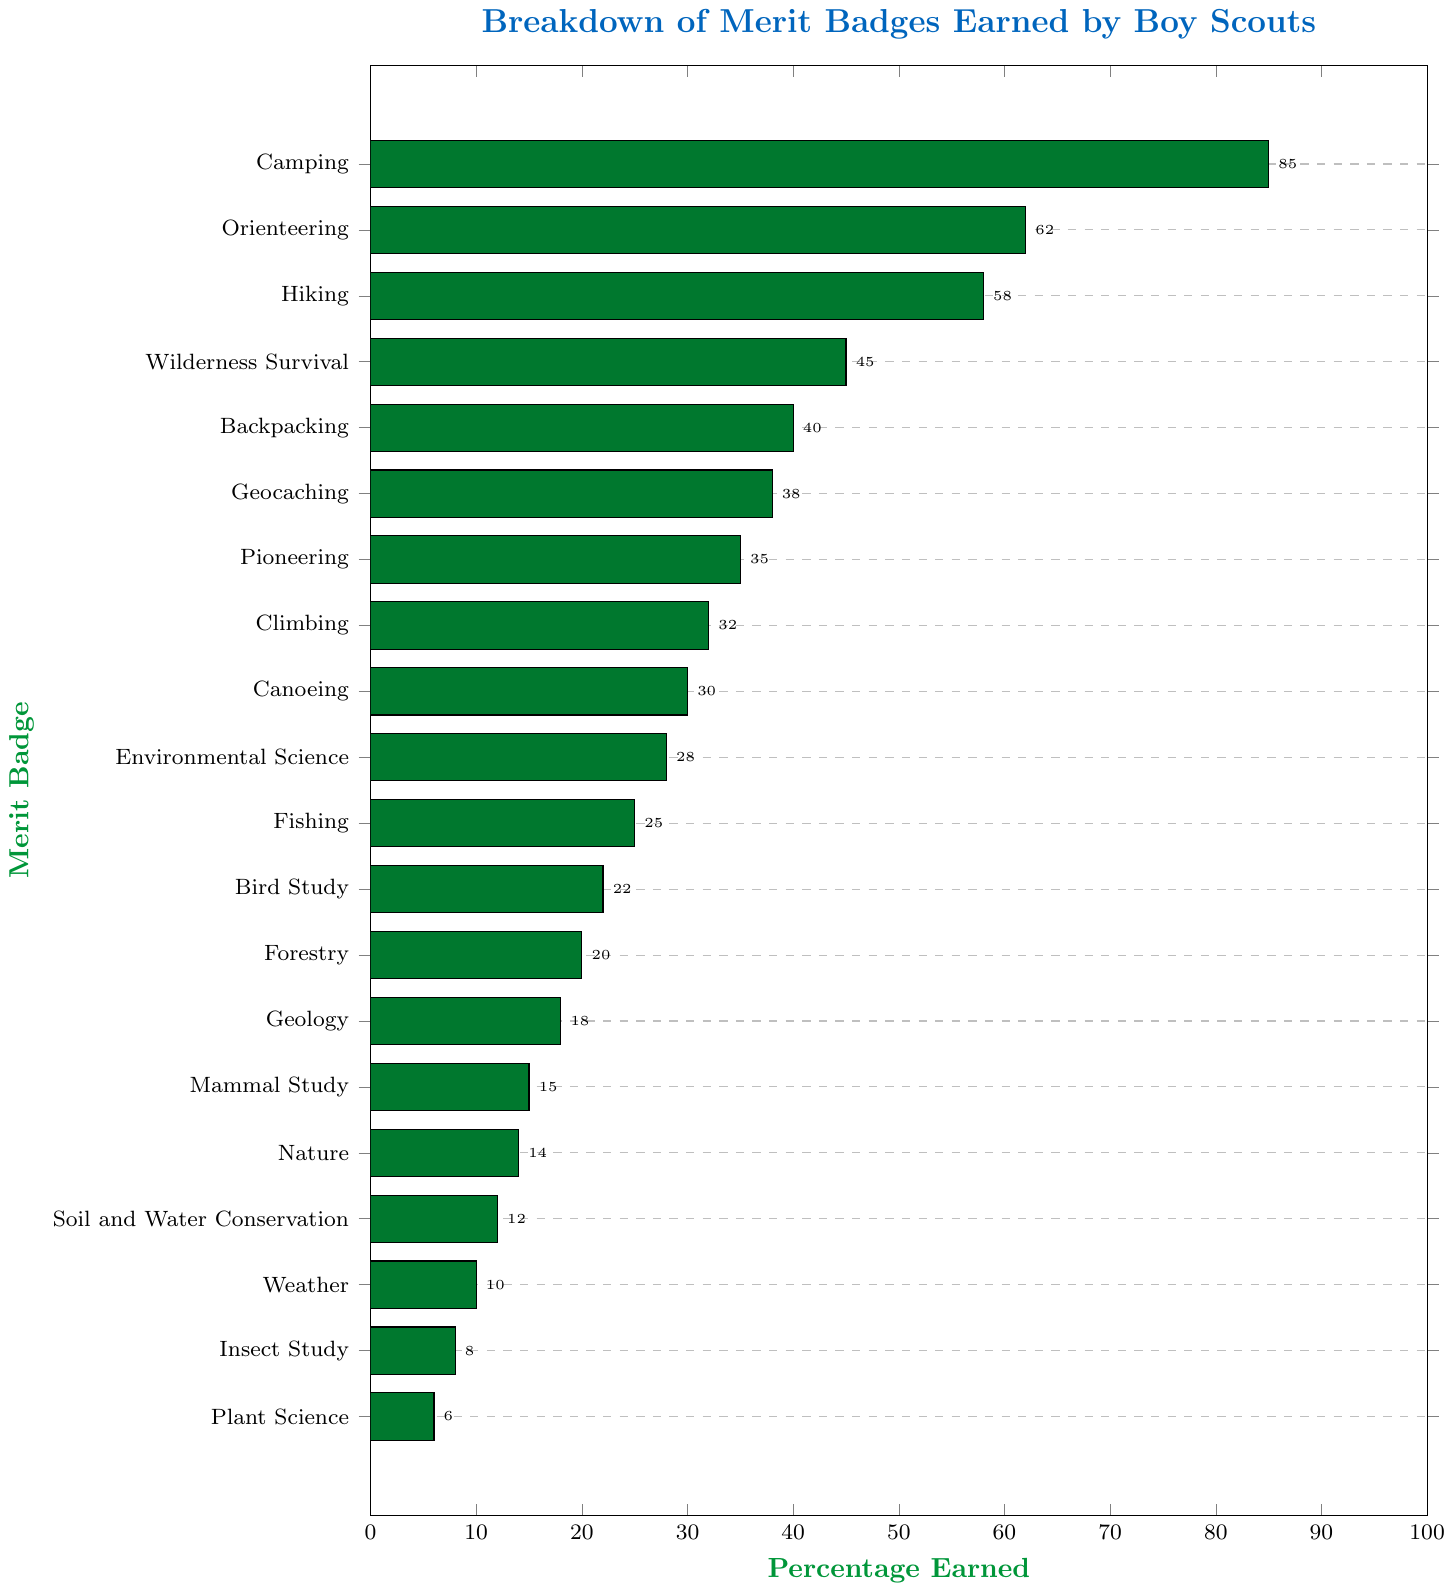Which merit badge has the highest percentage earned? Identify the bar with the greatest length, which represents the highest percentage earned. The merit badge labeled "Camping" has the longest bar.
Answer: Camping Which merit badge has the lowest percentage earned? Identify the bar with the shortest length, which represents the lowest percentage earned. The merit badge labeled "Plant Science" has the shortest bar.
Answer: Plant Science How many merit badges have a percentage earned greater than 50%? Count the merit badges whose bars extend beyond the 50% mark. The merit badges "Camping," "Orienteering," and "Hiking" meet this criterion.
Answer: 3 What is the difference in percentage earned between the "Camping" and "Geocaching" merit badges? Subtract the percentage earned for "Geocaching" (38) from the percentage earned for "Camping" (85). The difference is 85 - 38.
Answer: 47 Which merit badges fall within the 20-25% range? Identify the merit badges with bars extending between the 20% and 25% marks. The merit badges "Bird Study," "Forestry," and "Fishing" meet this criterion.
Answer: Bird Study, Forestry, Fishing What is the combined percentage earned for "Backpacking" and "Orienteering"? Sum the percentages earned for "Backpacking" (40) and "Orienteering" (62) to find the total. 40 + 62 = 102.
Answer: 102 Which has a higher percentage earned: "Climbing" or "Canoeing"? Compare the lengths of the bars for "Climbing" (32) and "Canoeing" (30). The bar for "Climbing" is slightly longer.
Answer: Climbing How many merit badges have a percentage earned less than 15%? Count the merit badges whose bars do not extend beyond the 15% mark. The merit badges "Mammal Study," "Nature," "Soil and Water Conservation," "Weather," "Insect Study," and "Plant Science" meet this criterion.
Answer: 6 What is the average percentage earned for the merit badges "Fishing," "Environmental Science," and "Bird Study"? Sum the percentages earned for "Fishing" (25), "Environmental Science" (28), and "Bird Study" (22), and then divide by the number of merit badges. (25 + 28 + 22) / 3 = 75 / 3 = 25.
Answer: 25 Is the percentage earned for "Hiking" closer to "Orienteering" or "Wilderness Survival"? Subtract the percentage earned for "Hiking" (58) from "Orienteering" (62) and "Wilderness Survival" (45). 62 - 58 = 4 and 58 - 45 = 13. The difference of 4 is smaller than 13, so "Hiking" is closer to "Orienteering."
Answer: Orienteering 